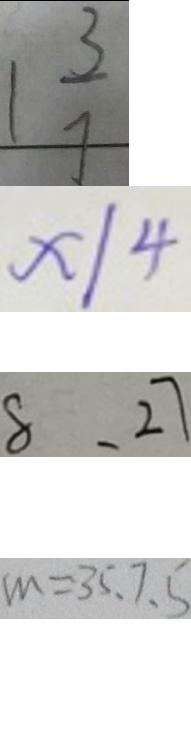Convert formula to latex. <formula><loc_0><loc_0><loc_500><loc_500>1 \frac { 3 } { 7 } 
 x \vert 4 
 8 , 2 7 
 m = 3 5 . 7 . 5</formula> 